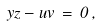Convert formula to latex. <formula><loc_0><loc_0><loc_500><loc_500>y z - u v \, = \, 0 \, ,</formula> 